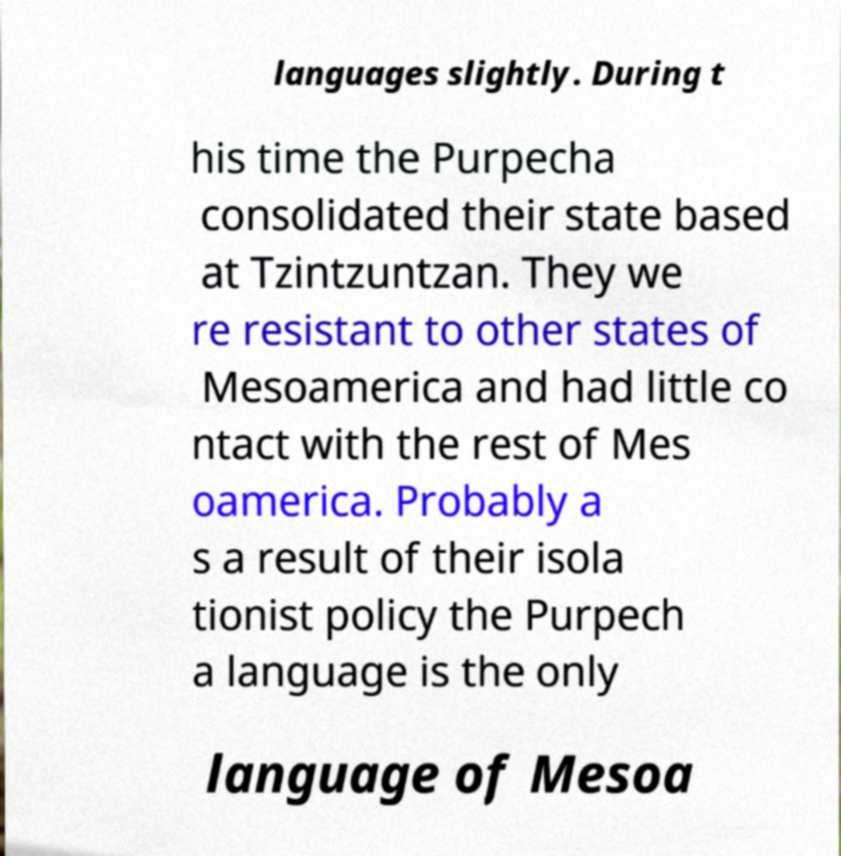Could you extract and type out the text from this image? languages slightly. During t his time the Purpecha consolidated their state based at Tzintzuntzan. They we re resistant to other states of Mesoamerica and had little co ntact with the rest of Mes oamerica. Probably a s a result of their isola tionist policy the Purpech a language is the only language of Mesoa 